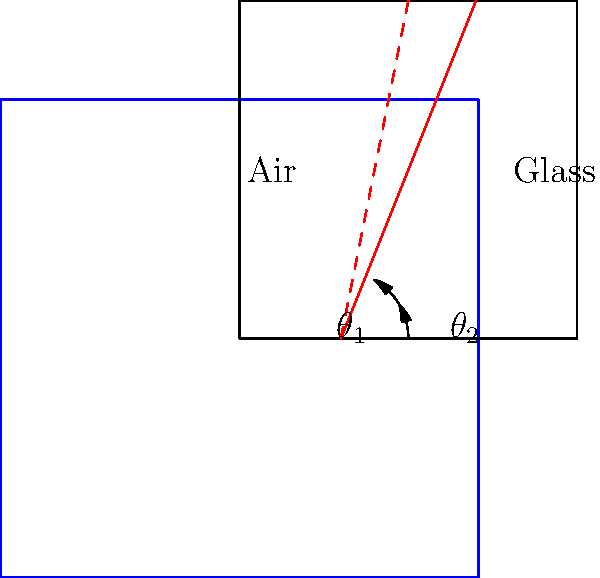In the stained glass window of Corbetta's historic church, a beam of light enters at an angle of $30^\circ$ to the normal. If the refractive index of the glass is 1.5, at what angle does the light emerge inside the glass? Round your answer to the nearest degree. To solve this problem, we'll use Snell's law, which describes the relationship between the angles of incidence and refraction for light passing through different media. The formula is:

$$n_1 \sin(\theta_1) = n_2 \sin(\theta_2)$$

Where:
$n_1$ is the refractive index of the first medium (air)
$n_2$ is the refractive index of the second medium (glass)
$\theta_1$ is the angle of incidence
$\theta_2$ is the angle of refraction

We know:
$n_1 = 1$ (refractive index of air)
$n_2 = 1.5$ (refractive index of glass)
$\theta_1 = 30^\circ$

Step 1: Substitute the known values into Snell's law:
$1 \sin(30^\circ) = 1.5 \sin(\theta_2)$

Step 2: Simplify the left side:
$0.5 = 1.5 \sin(\theta_2)$

Step 3: Solve for $\sin(\theta_2)$:
$\sin(\theta_2) = \frac{0.5}{1.5} = \frac{1}{3}$

Step 4: Take the inverse sine (arcsin) of both sides:
$\theta_2 = \arcsin(\frac{1}{3})$

Step 5: Calculate and round to the nearest degree:
$\theta_2 \approx 19.5^\circ \approx 20^\circ$

Therefore, the light emerges inside the glass at an angle of approximately 20° to the normal.
Answer: 20° 